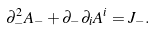Convert formula to latex. <formula><loc_0><loc_0><loc_500><loc_500>\partial _ { - } ^ { 2 } A _ { - } + \partial _ { - } \partial _ { i } A ^ { i } = J _ { - } .</formula> 